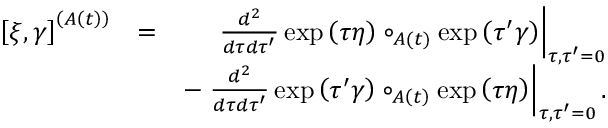<formula> <loc_0><loc_0><loc_500><loc_500>\begin{array} { r l r } { \left [ \xi , \gamma \right ] ^ { \left ( A \left ( t \right ) \right ) } } & { = } & { \frac { d ^ { 2 } } { d \tau d \tau ^ { \prime } } \exp \left ( \tau \eta \right ) \circ _ { A \left ( t \right ) } \exp \left ( \tau ^ { \prime } \gamma \right ) \right | _ { \tau , \tau ^ { \prime } = 0 } } \\ & { - \frac { d ^ { 2 } } { d \tau d \tau ^ { \prime } } \exp \left ( \tau ^ { \prime } \gamma \right ) \circ _ { A \left ( t \right ) } \exp \left ( \tau \eta \right ) \right | _ { \tau , \tau ^ { \prime } = 0 } . } \end{array}</formula> 